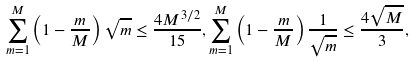<formula> <loc_0><loc_0><loc_500><loc_500>\sum _ { m = 1 } ^ { M } \left ( 1 - \frac { m } { M } \right ) \sqrt { m } \leq \frac { 4 M ^ { 3 / 2 } } { 1 5 } , \sum _ { m = 1 } ^ { M } \left ( 1 - \frac { m } { M } \right ) \frac { 1 } { \sqrt { m } } \leq \frac { 4 \sqrt { M } } { 3 } ,</formula> 